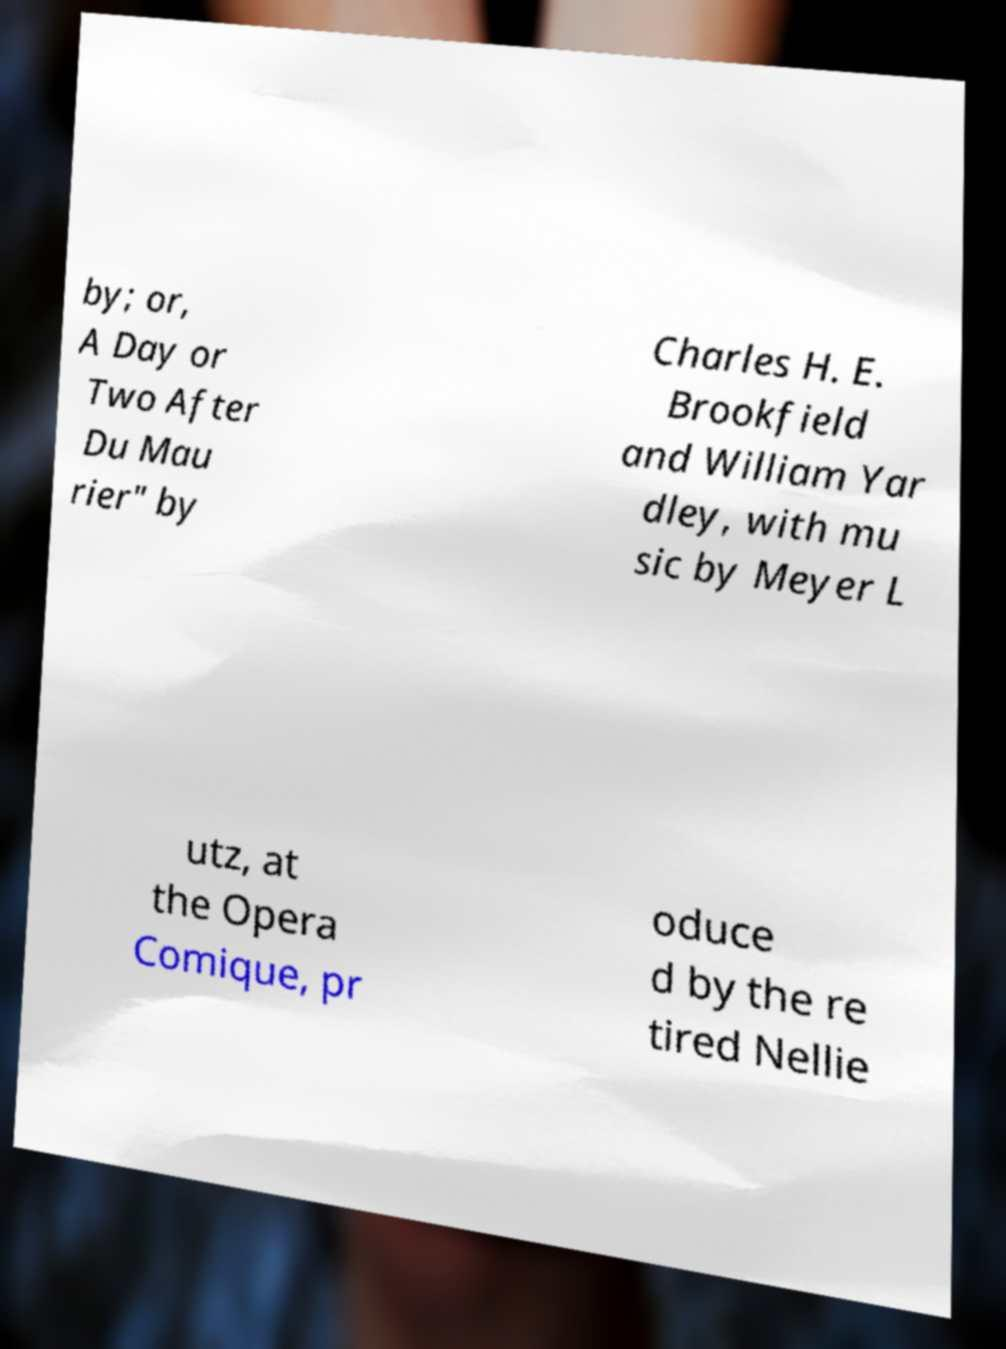For documentation purposes, I need the text within this image transcribed. Could you provide that? by; or, A Day or Two After Du Mau rier" by Charles H. E. Brookfield and William Yar dley, with mu sic by Meyer L utz, at the Opera Comique, pr oduce d by the re tired Nellie 